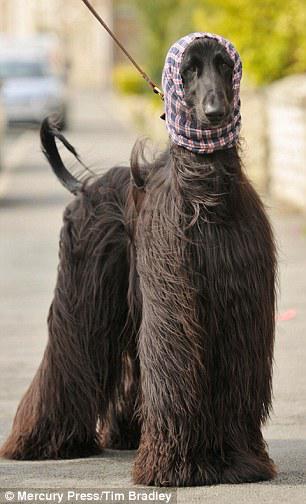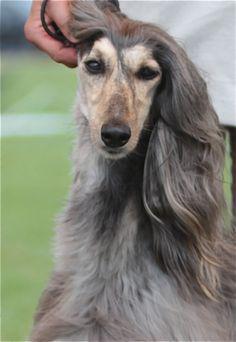The first image is the image on the left, the second image is the image on the right. Examine the images to the left and right. Is the description "A leash extends diagonally from a top corner to one of the afghan hounds." accurate? Answer yes or no. Yes. 